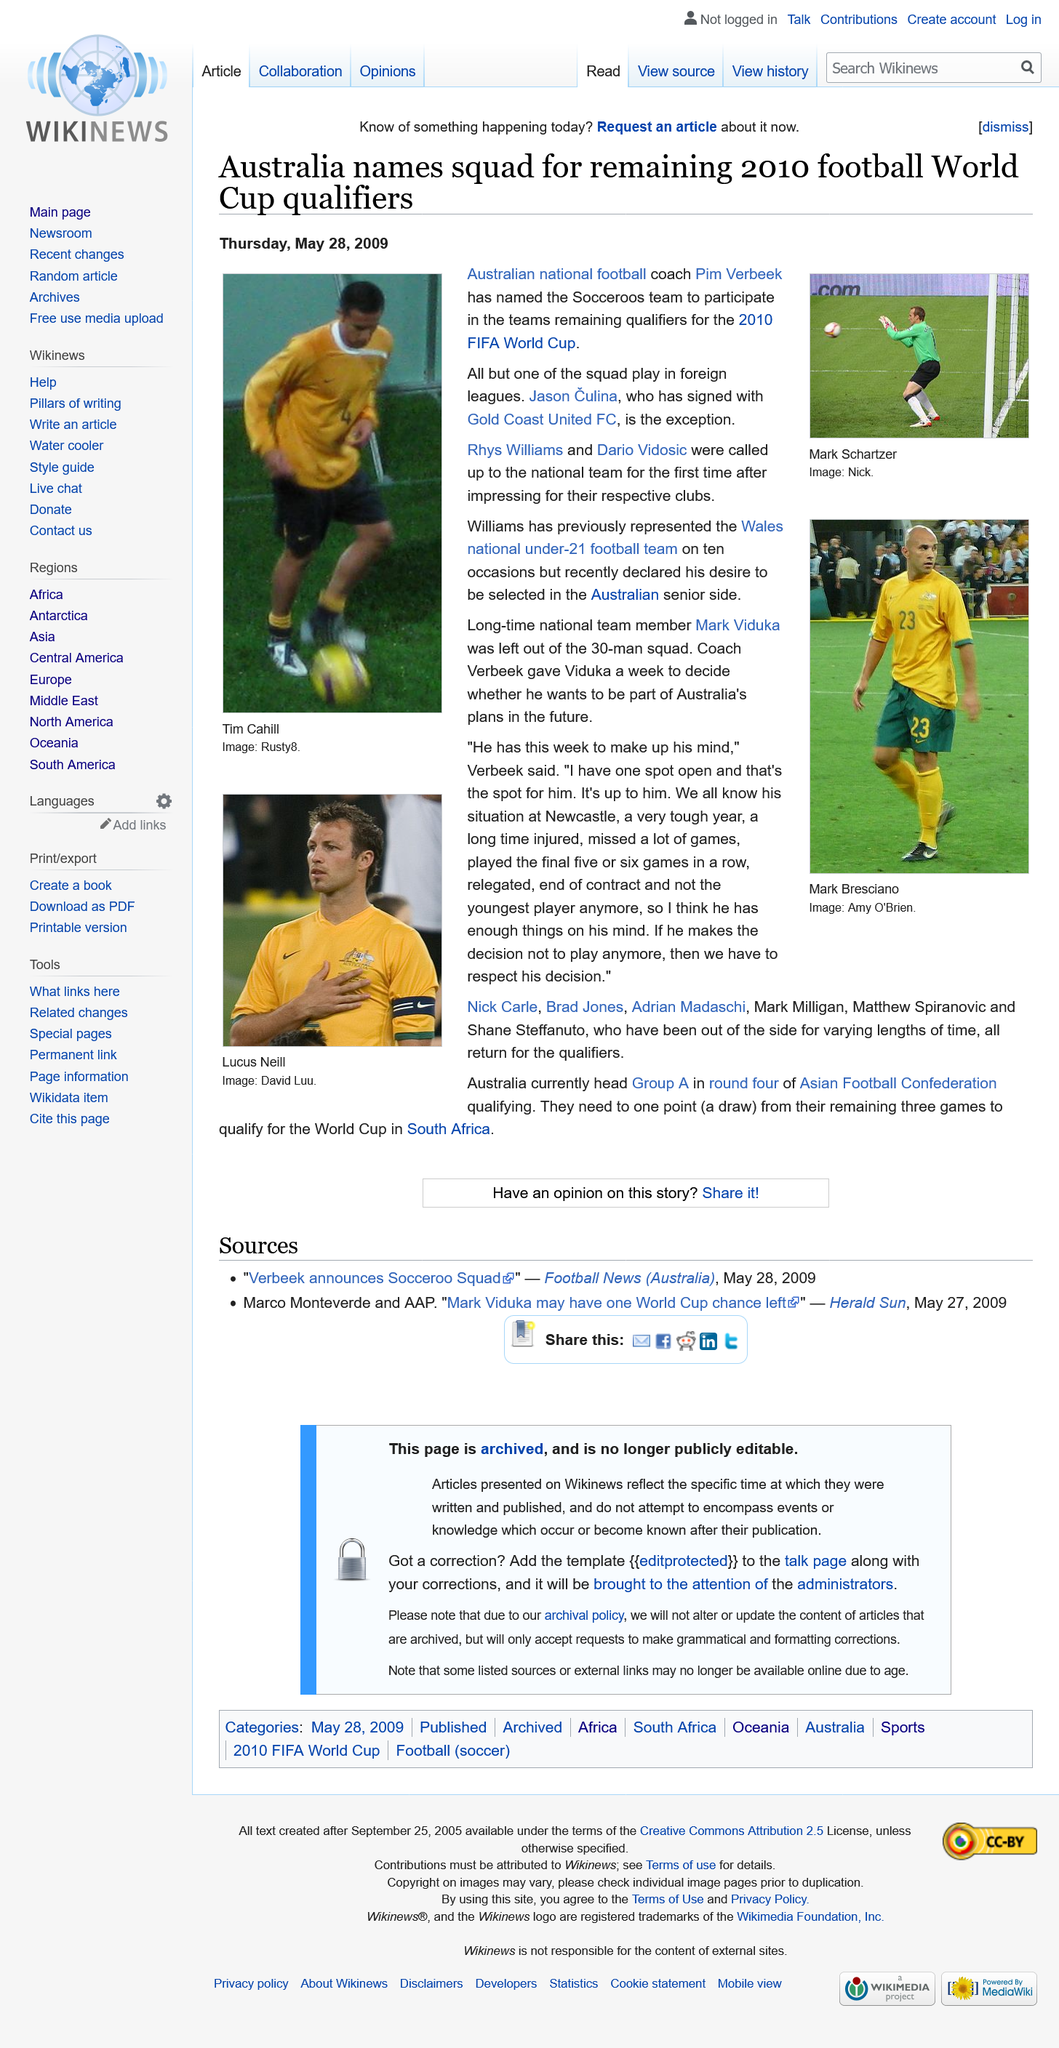Draw attention to some important aspects in this diagram. Rhys Williams has had the honor of representing the Wales national under-21 football team on ten occasions, demonstrating his commitment to the sport and his country. Jason Culina has signed with Gold Coast United FC. The Australian national football team has called up two new players, Rhys Williams and Dario Vidosic, for the first time. Pim Verbeek is the coach of the team. 